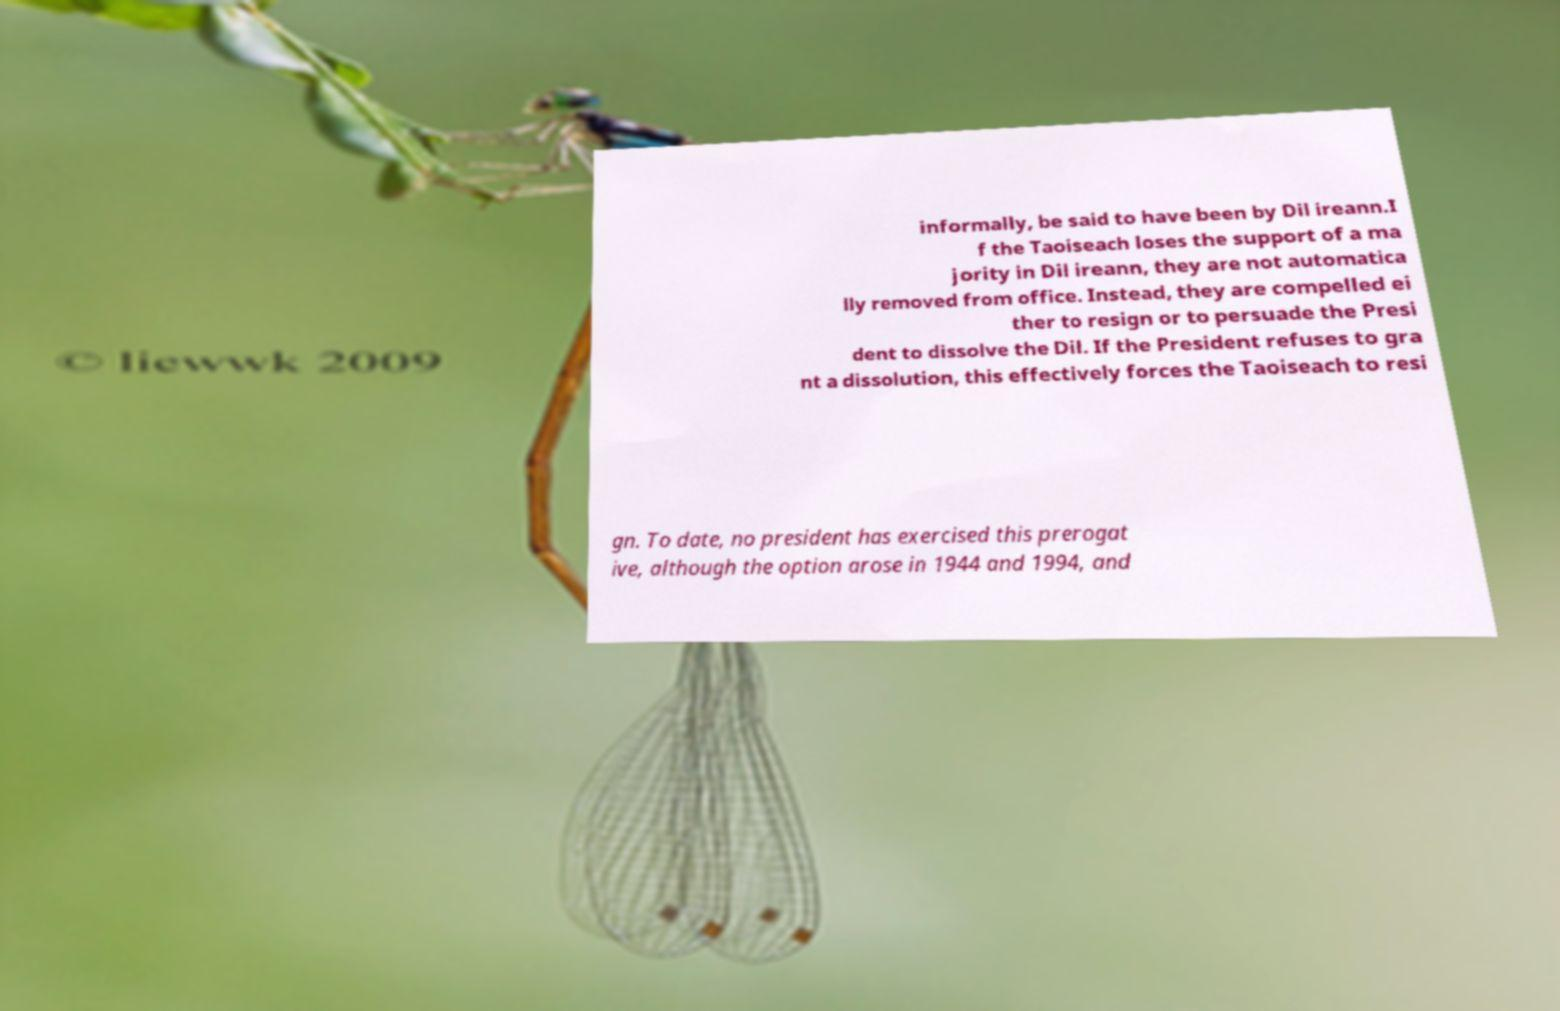Please identify and transcribe the text found in this image. informally, be said to have been by Dil ireann.I f the Taoiseach loses the support of a ma jority in Dil ireann, they are not automatica lly removed from office. Instead, they are compelled ei ther to resign or to persuade the Presi dent to dissolve the Dil. If the President refuses to gra nt a dissolution, this effectively forces the Taoiseach to resi gn. To date, no president has exercised this prerogat ive, although the option arose in 1944 and 1994, and 